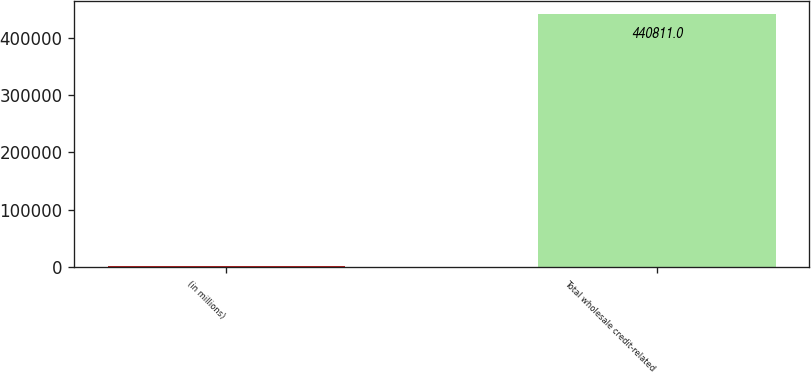<chart> <loc_0><loc_0><loc_500><loc_500><bar_chart><fcel>(in millions)<fcel>Total wholesale credit-related<nl><fcel>2008<fcel>440811<nl></chart> 